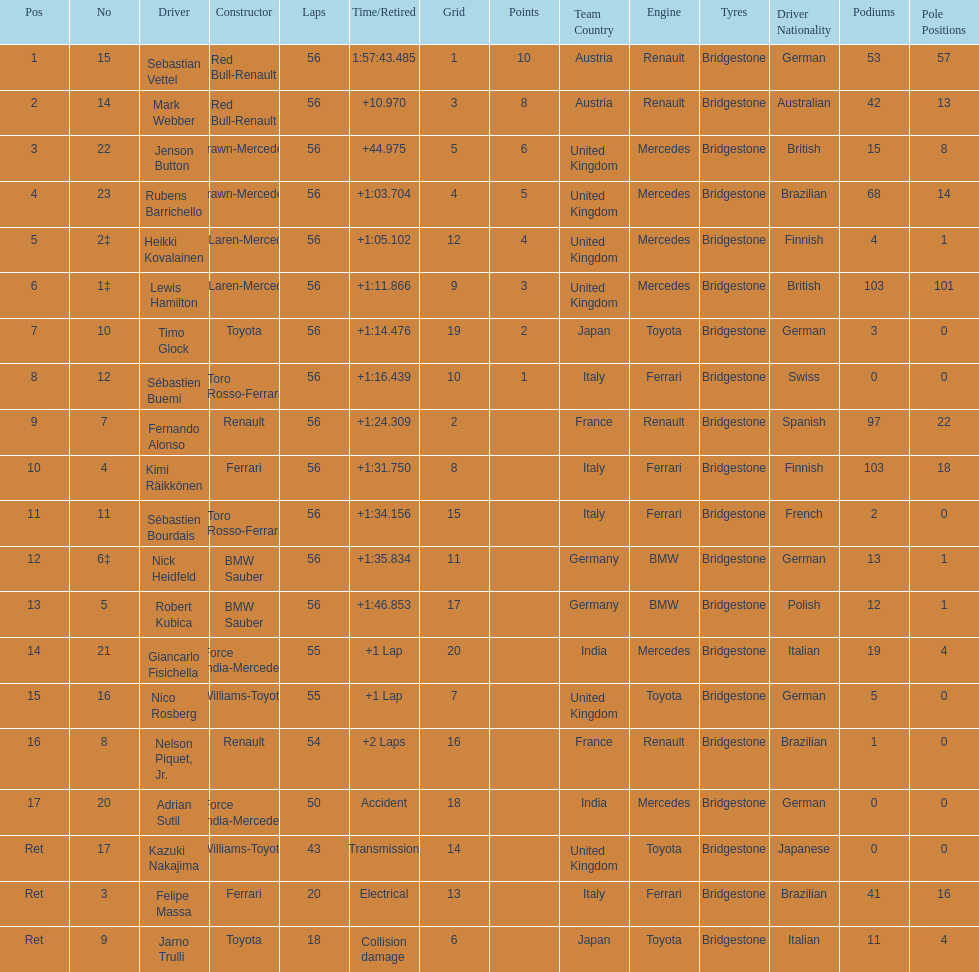Heikki kovalainen and lewis hamilton both had which constructor? McLaren-Mercedes. 